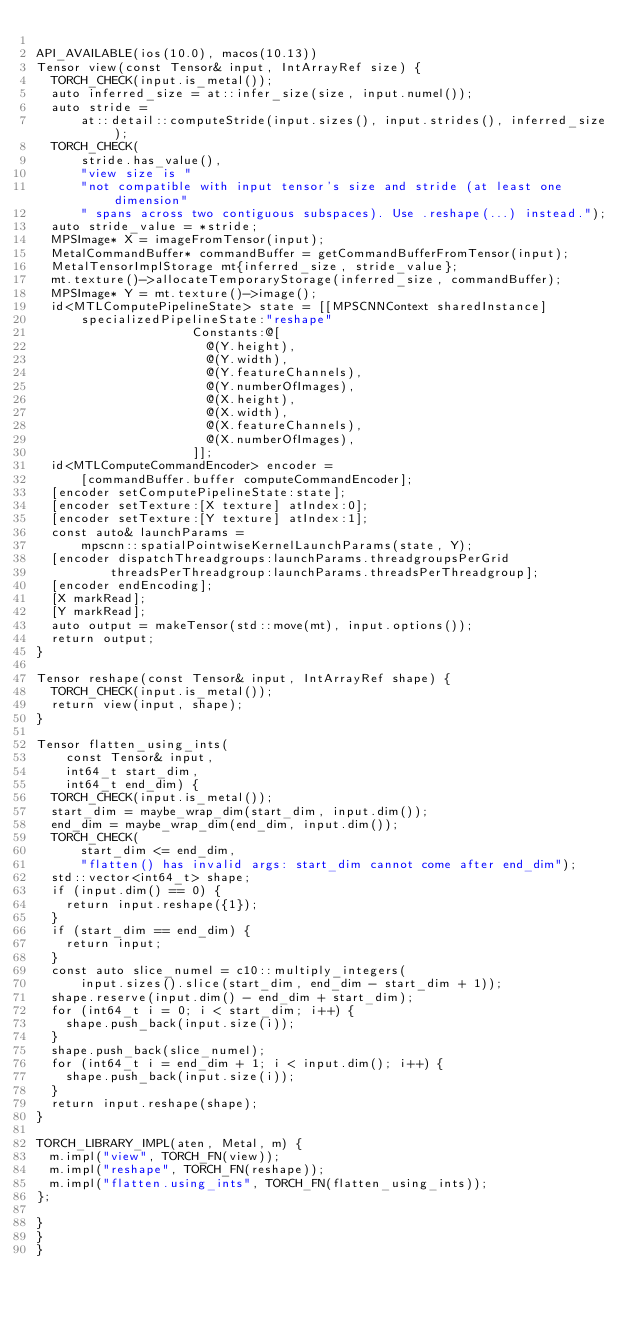<code> <loc_0><loc_0><loc_500><loc_500><_ObjectiveC_>
API_AVAILABLE(ios(10.0), macos(10.13))
Tensor view(const Tensor& input, IntArrayRef size) {
  TORCH_CHECK(input.is_metal());
  auto inferred_size = at::infer_size(size, input.numel());
  auto stride =
      at::detail::computeStride(input.sizes(), input.strides(), inferred_size);
  TORCH_CHECK(
      stride.has_value(),
      "view size is "
      "not compatible with input tensor's size and stride (at least one dimension"
      " spans across two contiguous subspaces). Use .reshape(...) instead.");
  auto stride_value = *stride;
  MPSImage* X = imageFromTensor(input);
  MetalCommandBuffer* commandBuffer = getCommandBufferFromTensor(input);
  MetalTensorImplStorage mt{inferred_size, stride_value};
  mt.texture()->allocateTemporaryStorage(inferred_size, commandBuffer);
  MPSImage* Y = mt.texture()->image();
  id<MTLComputePipelineState> state = [[MPSCNNContext sharedInstance]
      specializedPipelineState:"reshape"
                     Constants:@[
                       @(Y.height),
                       @(Y.width),
                       @(Y.featureChannels),
                       @(Y.numberOfImages),
                       @(X.height),
                       @(X.width),
                       @(X.featureChannels),
                       @(X.numberOfImages),
                     ]];
  id<MTLComputeCommandEncoder> encoder =
      [commandBuffer.buffer computeCommandEncoder];
  [encoder setComputePipelineState:state];
  [encoder setTexture:[X texture] atIndex:0];
  [encoder setTexture:[Y texture] atIndex:1];
  const auto& launchParams =
      mpscnn::spatialPointwiseKernelLaunchParams(state, Y);
  [encoder dispatchThreadgroups:launchParams.threadgroupsPerGrid
          threadsPerThreadgroup:launchParams.threadsPerThreadgroup];
  [encoder endEncoding];
  [X markRead];
  [Y markRead];
  auto output = makeTensor(std::move(mt), input.options());
  return output;
}

Tensor reshape(const Tensor& input, IntArrayRef shape) {
  TORCH_CHECK(input.is_metal());
  return view(input, shape);
}

Tensor flatten_using_ints(
    const Tensor& input,
    int64_t start_dim,
    int64_t end_dim) {
  TORCH_CHECK(input.is_metal());
  start_dim = maybe_wrap_dim(start_dim, input.dim());
  end_dim = maybe_wrap_dim(end_dim, input.dim());
  TORCH_CHECK(
      start_dim <= end_dim,
      "flatten() has invalid args: start_dim cannot come after end_dim");
  std::vector<int64_t> shape;
  if (input.dim() == 0) {
    return input.reshape({1});
  }
  if (start_dim == end_dim) {
    return input;
  }
  const auto slice_numel = c10::multiply_integers(
      input.sizes().slice(start_dim, end_dim - start_dim + 1));
  shape.reserve(input.dim() - end_dim + start_dim);
  for (int64_t i = 0; i < start_dim; i++) {
    shape.push_back(input.size(i));
  }
  shape.push_back(slice_numel);
  for (int64_t i = end_dim + 1; i < input.dim(); i++) {
    shape.push_back(input.size(i));
  }
  return input.reshape(shape);
}

TORCH_LIBRARY_IMPL(aten, Metal, m) {
  m.impl("view", TORCH_FN(view));
  m.impl("reshape", TORCH_FN(reshape));
  m.impl("flatten.using_ints", TORCH_FN(flatten_using_ints));
};

}
}
}
</code> 